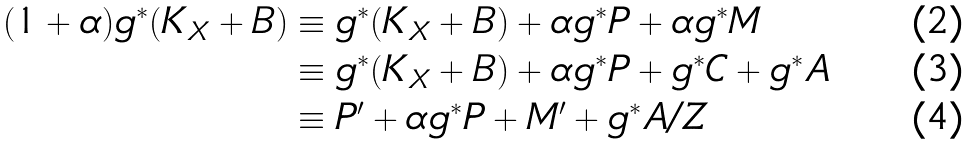<formula> <loc_0><loc_0><loc_500><loc_500>( 1 + \alpha ) g ^ { * } ( K _ { X } + B ) & \equiv g ^ { * } ( K _ { X } + B ) + \alpha g ^ { * } P + \alpha g ^ { * } M \\ & \equiv g ^ { * } ( K _ { X } + B ) + \alpha g ^ { * } P + g ^ { * } C + g ^ { * } A \\ & \equiv P ^ { \prime } + \alpha g ^ { * } P + M ^ { \prime } + g ^ { * } A / Z</formula> 